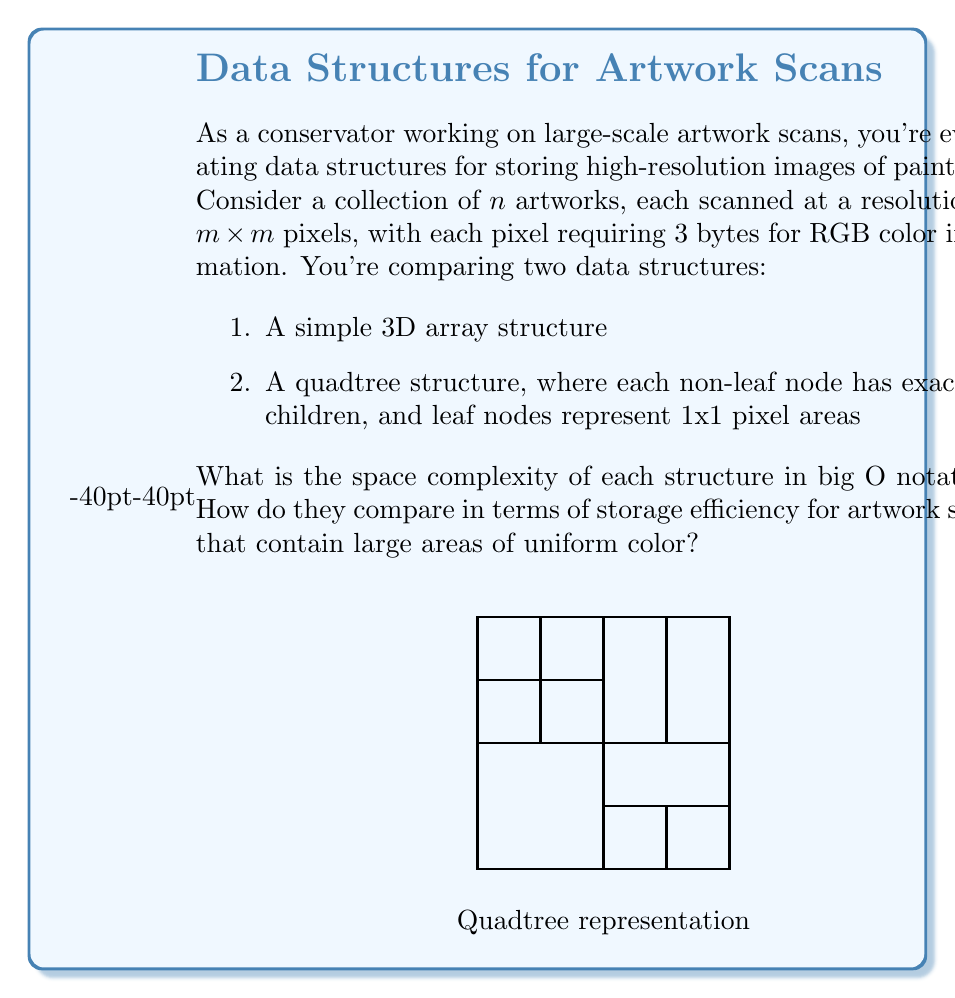Give your solution to this math problem. Let's analyze the space complexity of both data structures:

1. Simple 3D array structure:
   - For $n$ artworks, each with dimensions $m \times m$ and 3 bytes per pixel:
   - Total space: $n \times m \times m \times 3$ bytes
   - Space complexity: $O(nm^2)$

2. Quadtree structure:
   - Worst case (no uniform areas):
     - Each pixel becomes a leaf node
     - Number of internal nodes: $\sum_{i=0}^{\log_4(m^2)-1} 4^i = \frac{4^{\log_4(m^2)}-1}{3} = \frac{m^2-1}{3}$
     - Total nodes: $m^2 + \frac{m^2-1}{3} = \frac{4m^2-1}{3}$
   - For $n$ artworks: $n \times \frac{4m^2-1}{3}$ nodes
   - Each node stores 4 pointers (or pixel data for leaves)
   - Space complexity: $O(nm^2)$

However, the quadtree has an advantage for artworks with large uniform color areas:
- Best case (completely uniform artwork):
  - Only one leaf node for the entire image
  - $\log_4(m^2)$ internal nodes
  - Total nodes: $\log_4(m^2) + 1$
  - Space complexity: $O(n\log m)$

In practice, most artworks will fall between these extremes. The quadtree structure can potentially save significant space for artworks with large uniform areas or gradual color transitions, which is common in many paintings.

From a conservator's perspective, the quadtree structure might be preferable as it can preserve the original color information more efficiently, potentially allowing for storage of higher resolution scans within the same space constraints. This could be crucial for accurate restoration work without altering the original intention of the artwork.
Answer: Both: $O(nm^2)$ worst case. Quadtree: $O(n\log m)$ best case, more efficient for uniform areas. 